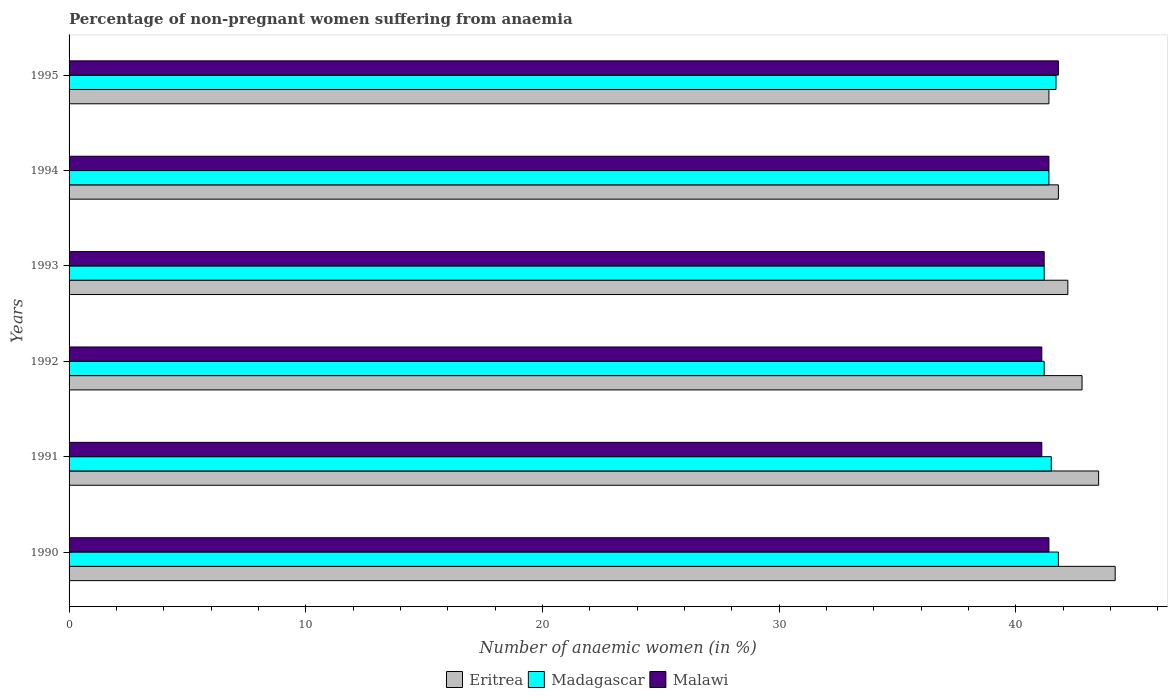Are the number of bars per tick equal to the number of legend labels?
Ensure brevity in your answer.  Yes. Are the number of bars on each tick of the Y-axis equal?
Your response must be concise. Yes. What is the label of the 5th group of bars from the top?
Offer a very short reply. 1991. What is the percentage of non-pregnant women suffering from anaemia in Malawi in 1992?
Provide a succinct answer. 41.1. Across all years, what is the maximum percentage of non-pregnant women suffering from anaemia in Madagascar?
Give a very brief answer. 41.8. Across all years, what is the minimum percentage of non-pregnant women suffering from anaemia in Madagascar?
Provide a short and direct response. 41.2. In which year was the percentage of non-pregnant women suffering from anaemia in Malawi maximum?
Your answer should be very brief. 1995. What is the total percentage of non-pregnant women suffering from anaemia in Madagascar in the graph?
Your answer should be very brief. 248.8. What is the difference between the percentage of non-pregnant women suffering from anaemia in Madagascar in 1991 and that in 1994?
Provide a succinct answer. 0.1. What is the difference between the percentage of non-pregnant women suffering from anaemia in Eritrea in 1990 and the percentage of non-pregnant women suffering from anaemia in Madagascar in 1991?
Your answer should be compact. 2.7. What is the average percentage of non-pregnant women suffering from anaemia in Madagascar per year?
Keep it short and to the point. 41.47. In the year 1992, what is the difference between the percentage of non-pregnant women suffering from anaemia in Malawi and percentage of non-pregnant women suffering from anaemia in Madagascar?
Keep it short and to the point. -0.1. In how many years, is the percentage of non-pregnant women suffering from anaemia in Eritrea greater than 28 %?
Your answer should be compact. 6. What is the ratio of the percentage of non-pregnant women suffering from anaemia in Eritrea in 1993 to that in 1994?
Offer a terse response. 1.01. Is the percentage of non-pregnant women suffering from anaemia in Eritrea in 1990 less than that in 1994?
Provide a short and direct response. No. Is the difference between the percentage of non-pregnant women suffering from anaemia in Malawi in 1993 and 1994 greater than the difference between the percentage of non-pregnant women suffering from anaemia in Madagascar in 1993 and 1994?
Ensure brevity in your answer.  No. What is the difference between the highest and the second highest percentage of non-pregnant women suffering from anaemia in Malawi?
Make the answer very short. 0.4. What is the difference between the highest and the lowest percentage of non-pregnant women suffering from anaemia in Madagascar?
Provide a succinct answer. 0.6. In how many years, is the percentage of non-pregnant women suffering from anaemia in Madagascar greater than the average percentage of non-pregnant women suffering from anaemia in Madagascar taken over all years?
Make the answer very short. 3. Is the sum of the percentage of non-pregnant women suffering from anaemia in Malawi in 1993 and 1995 greater than the maximum percentage of non-pregnant women suffering from anaemia in Madagascar across all years?
Ensure brevity in your answer.  Yes. What does the 3rd bar from the top in 1993 represents?
Make the answer very short. Eritrea. What does the 1st bar from the bottom in 1994 represents?
Offer a terse response. Eritrea. Is it the case that in every year, the sum of the percentage of non-pregnant women suffering from anaemia in Malawi and percentage of non-pregnant women suffering from anaemia in Madagascar is greater than the percentage of non-pregnant women suffering from anaemia in Eritrea?
Your answer should be very brief. Yes. Are all the bars in the graph horizontal?
Your response must be concise. Yes. What is the difference between two consecutive major ticks on the X-axis?
Offer a terse response. 10. Where does the legend appear in the graph?
Your answer should be compact. Bottom center. How are the legend labels stacked?
Provide a succinct answer. Horizontal. What is the title of the graph?
Make the answer very short. Percentage of non-pregnant women suffering from anaemia. What is the label or title of the X-axis?
Offer a very short reply. Number of anaemic women (in %). What is the Number of anaemic women (in %) in Eritrea in 1990?
Keep it short and to the point. 44.2. What is the Number of anaemic women (in %) of Madagascar in 1990?
Ensure brevity in your answer.  41.8. What is the Number of anaemic women (in %) of Malawi in 1990?
Keep it short and to the point. 41.4. What is the Number of anaemic women (in %) in Eritrea in 1991?
Your answer should be very brief. 43.5. What is the Number of anaemic women (in %) of Madagascar in 1991?
Make the answer very short. 41.5. What is the Number of anaemic women (in %) of Malawi in 1991?
Provide a succinct answer. 41.1. What is the Number of anaemic women (in %) in Eritrea in 1992?
Provide a short and direct response. 42.8. What is the Number of anaemic women (in %) in Madagascar in 1992?
Your response must be concise. 41.2. What is the Number of anaemic women (in %) of Malawi in 1992?
Provide a short and direct response. 41.1. What is the Number of anaemic women (in %) in Eritrea in 1993?
Give a very brief answer. 42.2. What is the Number of anaemic women (in %) of Madagascar in 1993?
Provide a short and direct response. 41.2. What is the Number of anaemic women (in %) of Malawi in 1993?
Offer a terse response. 41.2. What is the Number of anaemic women (in %) of Eritrea in 1994?
Your answer should be very brief. 41.8. What is the Number of anaemic women (in %) of Madagascar in 1994?
Make the answer very short. 41.4. What is the Number of anaemic women (in %) in Malawi in 1994?
Your response must be concise. 41.4. What is the Number of anaemic women (in %) in Eritrea in 1995?
Ensure brevity in your answer.  41.4. What is the Number of anaemic women (in %) of Madagascar in 1995?
Offer a terse response. 41.7. What is the Number of anaemic women (in %) of Malawi in 1995?
Make the answer very short. 41.8. Across all years, what is the maximum Number of anaemic women (in %) in Eritrea?
Your answer should be very brief. 44.2. Across all years, what is the maximum Number of anaemic women (in %) in Madagascar?
Provide a succinct answer. 41.8. Across all years, what is the maximum Number of anaemic women (in %) in Malawi?
Make the answer very short. 41.8. Across all years, what is the minimum Number of anaemic women (in %) in Eritrea?
Offer a terse response. 41.4. Across all years, what is the minimum Number of anaemic women (in %) in Madagascar?
Your answer should be very brief. 41.2. Across all years, what is the minimum Number of anaemic women (in %) of Malawi?
Offer a terse response. 41.1. What is the total Number of anaemic women (in %) in Eritrea in the graph?
Your answer should be compact. 255.9. What is the total Number of anaemic women (in %) in Madagascar in the graph?
Offer a very short reply. 248.8. What is the total Number of anaemic women (in %) of Malawi in the graph?
Keep it short and to the point. 248. What is the difference between the Number of anaemic women (in %) of Eritrea in 1990 and that in 1991?
Ensure brevity in your answer.  0.7. What is the difference between the Number of anaemic women (in %) of Madagascar in 1990 and that in 1991?
Your answer should be very brief. 0.3. What is the difference between the Number of anaemic women (in %) of Malawi in 1990 and that in 1991?
Provide a succinct answer. 0.3. What is the difference between the Number of anaemic women (in %) of Eritrea in 1990 and that in 1992?
Give a very brief answer. 1.4. What is the difference between the Number of anaemic women (in %) of Madagascar in 1990 and that in 1992?
Ensure brevity in your answer.  0.6. What is the difference between the Number of anaemic women (in %) in Malawi in 1990 and that in 1993?
Offer a terse response. 0.2. What is the difference between the Number of anaemic women (in %) in Eritrea in 1990 and that in 1995?
Your response must be concise. 2.8. What is the difference between the Number of anaemic women (in %) in Malawi in 1990 and that in 1995?
Offer a terse response. -0.4. What is the difference between the Number of anaemic women (in %) in Eritrea in 1991 and that in 1993?
Offer a very short reply. 1.3. What is the difference between the Number of anaemic women (in %) in Malawi in 1991 and that in 1993?
Ensure brevity in your answer.  -0.1. What is the difference between the Number of anaemic women (in %) of Malawi in 1991 and that in 1994?
Your answer should be compact. -0.3. What is the difference between the Number of anaemic women (in %) of Eritrea in 1991 and that in 1995?
Provide a succinct answer. 2.1. What is the difference between the Number of anaemic women (in %) of Madagascar in 1992 and that in 1993?
Your answer should be compact. 0. What is the difference between the Number of anaemic women (in %) in Eritrea in 1992 and that in 1994?
Your answer should be compact. 1. What is the difference between the Number of anaemic women (in %) of Madagascar in 1992 and that in 1994?
Offer a terse response. -0.2. What is the difference between the Number of anaemic women (in %) in Madagascar in 1992 and that in 1995?
Your answer should be very brief. -0.5. What is the difference between the Number of anaemic women (in %) of Madagascar in 1993 and that in 1994?
Offer a very short reply. -0.2. What is the difference between the Number of anaemic women (in %) of Eritrea in 1993 and that in 1995?
Give a very brief answer. 0.8. What is the difference between the Number of anaemic women (in %) of Malawi in 1993 and that in 1995?
Ensure brevity in your answer.  -0.6. What is the difference between the Number of anaemic women (in %) of Madagascar in 1990 and the Number of anaemic women (in %) of Malawi in 1991?
Your answer should be very brief. 0.7. What is the difference between the Number of anaemic women (in %) of Eritrea in 1990 and the Number of anaemic women (in %) of Malawi in 1992?
Ensure brevity in your answer.  3.1. What is the difference between the Number of anaemic women (in %) in Madagascar in 1990 and the Number of anaemic women (in %) in Malawi in 1992?
Your response must be concise. 0.7. What is the difference between the Number of anaemic women (in %) of Eritrea in 1990 and the Number of anaemic women (in %) of Madagascar in 1993?
Give a very brief answer. 3. What is the difference between the Number of anaemic women (in %) in Eritrea in 1990 and the Number of anaemic women (in %) in Malawi in 1993?
Your answer should be very brief. 3. What is the difference between the Number of anaemic women (in %) of Madagascar in 1990 and the Number of anaemic women (in %) of Malawi in 1993?
Make the answer very short. 0.6. What is the difference between the Number of anaemic women (in %) in Madagascar in 1990 and the Number of anaemic women (in %) in Malawi in 1995?
Provide a succinct answer. 0. What is the difference between the Number of anaemic women (in %) of Eritrea in 1991 and the Number of anaemic women (in %) of Malawi in 1992?
Give a very brief answer. 2.4. What is the difference between the Number of anaemic women (in %) in Madagascar in 1991 and the Number of anaemic women (in %) in Malawi in 1992?
Keep it short and to the point. 0.4. What is the difference between the Number of anaemic women (in %) of Eritrea in 1991 and the Number of anaemic women (in %) of Madagascar in 1994?
Your answer should be very brief. 2.1. What is the difference between the Number of anaemic women (in %) in Eritrea in 1991 and the Number of anaemic women (in %) in Malawi in 1994?
Make the answer very short. 2.1. What is the difference between the Number of anaemic women (in %) of Eritrea in 1991 and the Number of anaemic women (in %) of Malawi in 1995?
Your answer should be compact. 1.7. What is the difference between the Number of anaemic women (in %) in Madagascar in 1992 and the Number of anaemic women (in %) in Malawi in 1993?
Offer a terse response. 0. What is the difference between the Number of anaemic women (in %) of Eritrea in 1992 and the Number of anaemic women (in %) of Madagascar in 1994?
Keep it short and to the point. 1.4. What is the difference between the Number of anaemic women (in %) of Eritrea in 1992 and the Number of anaemic women (in %) of Malawi in 1994?
Provide a succinct answer. 1.4. What is the difference between the Number of anaemic women (in %) of Madagascar in 1993 and the Number of anaemic women (in %) of Malawi in 1994?
Your answer should be very brief. -0.2. What is the difference between the Number of anaemic women (in %) in Madagascar in 1993 and the Number of anaemic women (in %) in Malawi in 1995?
Make the answer very short. -0.6. What is the difference between the Number of anaemic women (in %) in Eritrea in 1994 and the Number of anaemic women (in %) in Madagascar in 1995?
Offer a very short reply. 0.1. What is the difference between the Number of anaemic women (in %) in Eritrea in 1994 and the Number of anaemic women (in %) in Malawi in 1995?
Your response must be concise. 0. What is the difference between the Number of anaemic women (in %) in Madagascar in 1994 and the Number of anaemic women (in %) in Malawi in 1995?
Your answer should be compact. -0.4. What is the average Number of anaemic women (in %) of Eritrea per year?
Your answer should be very brief. 42.65. What is the average Number of anaemic women (in %) of Madagascar per year?
Your answer should be compact. 41.47. What is the average Number of anaemic women (in %) of Malawi per year?
Offer a very short reply. 41.33. In the year 1991, what is the difference between the Number of anaemic women (in %) in Eritrea and Number of anaemic women (in %) in Malawi?
Offer a very short reply. 2.4. In the year 1992, what is the difference between the Number of anaemic women (in %) in Madagascar and Number of anaemic women (in %) in Malawi?
Your answer should be very brief. 0.1. In the year 1993, what is the difference between the Number of anaemic women (in %) in Eritrea and Number of anaemic women (in %) in Madagascar?
Make the answer very short. 1. In the year 1993, what is the difference between the Number of anaemic women (in %) of Eritrea and Number of anaemic women (in %) of Malawi?
Make the answer very short. 1. In the year 1993, what is the difference between the Number of anaemic women (in %) in Madagascar and Number of anaemic women (in %) in Malawi?
Your answer should be compact. 0. In the year 1994, what is the difference between the Number of anaemic women (in %) of Eritrea and Number of anaemic women (in %) of Madagascar?
Ensure brevity in your answer.  0.4. In the year 1995, what is the difference between the Number of anaemic women (in %) of Madagascar and Number of anaemic women (in %) of Malawi?
Make the answer very short. -0.1. What is the ratio of the Number of anaemic women (in %) of Eritrea in 1990 to that in 1991?
Offer a very short reply. 1.02. What is the ratio of the Number of anaemic women (in %) in Madagascar in 1990 to that in 1991?
Your answer should be very brief. 1.01. What is the ratio of the Number of anaemic women (in %) of Malawi in 1990 to that in 1991?
Make the answer very short. 1.01. What is the ratio of the Number of anaemic women (in %) in Eritrea in 1990 to that in 1992?
Make the answer very short. 1.03. What is the ratio of the Number of anaemic women (in %) of Madagascar in 1990 to that in 1992?
Offer a terse response. 1.01. What is the ratio of the Number of anaemic women (in %) of Malawi in 1990 to that in 1992?
Your answer should be very brief. 1.01. What is the ratio of the Number of anaemic women (in %) of Eritrea in 1990 to that in 1993?
Offer a very short reply. 1.05. What is the ratio of the Number of anaemic women (in %) of Madagascar in 1990 to that in 1993?
Offer a very short reply. 1.01. What is the ratio of the Number of anaemic women (in %) of Malawi in 1990 to that in 1993?
Offer a terse response. 1. What is the ratio of the Number of anaemic women (in %) in Eritrea in 1990 to that in 1994?
Ensure brevity in your answer.  1.06. What is the ratio of the Number of anaemic women (in %) of Madagascar in 1990 to that in 1994?
Give a very brief answer. 1.01. What is the ratio of the Number of anaemic women (in %) in Eritrea in 1990 to that in 1995?
Keep it short and to the point. 1.07. What is the ratio of the Number of anaemic women (in %) in Madagascar in 1990 to that in 1995?
Offer a terse response. 1. What is the ratio of the Number of anaemic women (in %) of Malawi in 1990 to that in 1995?
Give a very brief answer. 0.99. What is the ratio of the Number of anaemic women (in %) of Eritrea in 1991 to that in 1992?
Your response must be concise. 1.02. What is the ratio of the Number of anaemic women (in %) of Madagascar in 1991 to that in 1992?
Your answer should be very brief. 1.01. What is the ratio of the Number of anaemic women (in %) in Malawi in 1991 to that in 1992?
Make the answer very short. 1. What is the ratio of the Number of anaemic women (in %) of Eritrea in 1991 to that in 1993?
Offer a terse response. 1.03. What is the ratio of the Number of anaemic women (in %) in Madagascar in 1991 to that in 1993?
Your response must be concise. 1.01. What is the ratio of the Number of anaemic women (in %) of Malawi in 1991 to that in 1993?
Offer a very short reply. 1. What is the ratio of the Number of anaemic women (in %) of Eritrea in 1991 to that in 1994?
Keep it short and to the point. 1.04. What is the ratio of the Number of anaemic women (in %) in Malawi in 1991 to that in 1994?
Your response must be concise. 0.99. What is the ratio of the Number of anaemic women (in %) in Eritrea in 1991 to that in 1995?
Your answer should be very brief. 1.05. What is the ratio of the Number of anaemic women (in %) in Madagascar in 1991 to that in 1995?
Offer a terse response. 1. What is the ratio of the Number of anaemic women (in %) of Malawi in 1991 to that in 1995?
Offer a very short reply. 0.98. What is the ratio of the Number of anaemic women (in %) in Eritrea in 1992 to that in 1993?
Your response must be concise. 1.01. What is the ratio of the Number of anaemic women (in %) of Madagascar in 1992 to that in 1993?
Provide a short and direct response. 1. What is the ratio of the Number of anaemic women (in %) in Eritrea in 1992 to that in 1994?
Ensure brevity in your answer.  1.02. What is the ratio of the Number of anaemic women (in %) in Malawi in 1992 to that in 1994?
Give a very brief answer. 0.99. What is the ratio of the Number of anaemic women (in %) of Eritrea in 1992 to that in 1995?
Give a very brief answer. 1.03. What is the ratio of the Number of anaemic women (in %) of Malawi in 1992 to that in 1995?
Your answer should be compact. 0.98. What is the ratio of the Number of anaemic women (in %) in Eritrea in 1993 to that in 1994?
Your answer should be very brief. 1.01. What is the ratio of the Number of anaemic women (in %) of Madagascar in 1993 to that in 1994?
Your answer should be very brief. 1. What is the ratio of the Number of anaemic women (in %) in Malawi in 1993 to that in 1994?
Make the answer very short. 1. What is the ratio of the Number of anaemic women (in %) of Eritrea in 1993 to that in 1995?
Give a very brief answer. 1.02. What is the ratio of the Number of anaemic women (in %) in Malawi in 1993 to that in 1995?
Your answer should be compact. 0.99. What is the ratio of the Number of anaemic women (in %) in Eritrea in 1994 to that in 1995?
Provide a succinct answer. 1.01. What is the ratio of the Number of anaemic women (in %) in Malawi in 1994 to that in 1995?
Your answer should be compact. 0.99. What is the difference between the highest and the second highest Number of anaemic women (in %) in Eritrea?
Give a very brief answer. 0.7. What is the difference between the highest and the second highest Number of anaemic women (in %) of Madagascar?
Provide a short and direct response. 0.1. What is the difference between the highest and the lowest Number of anaemic women (in %) in Eritrea?
Ensure brevity in your answer.  2.8. 